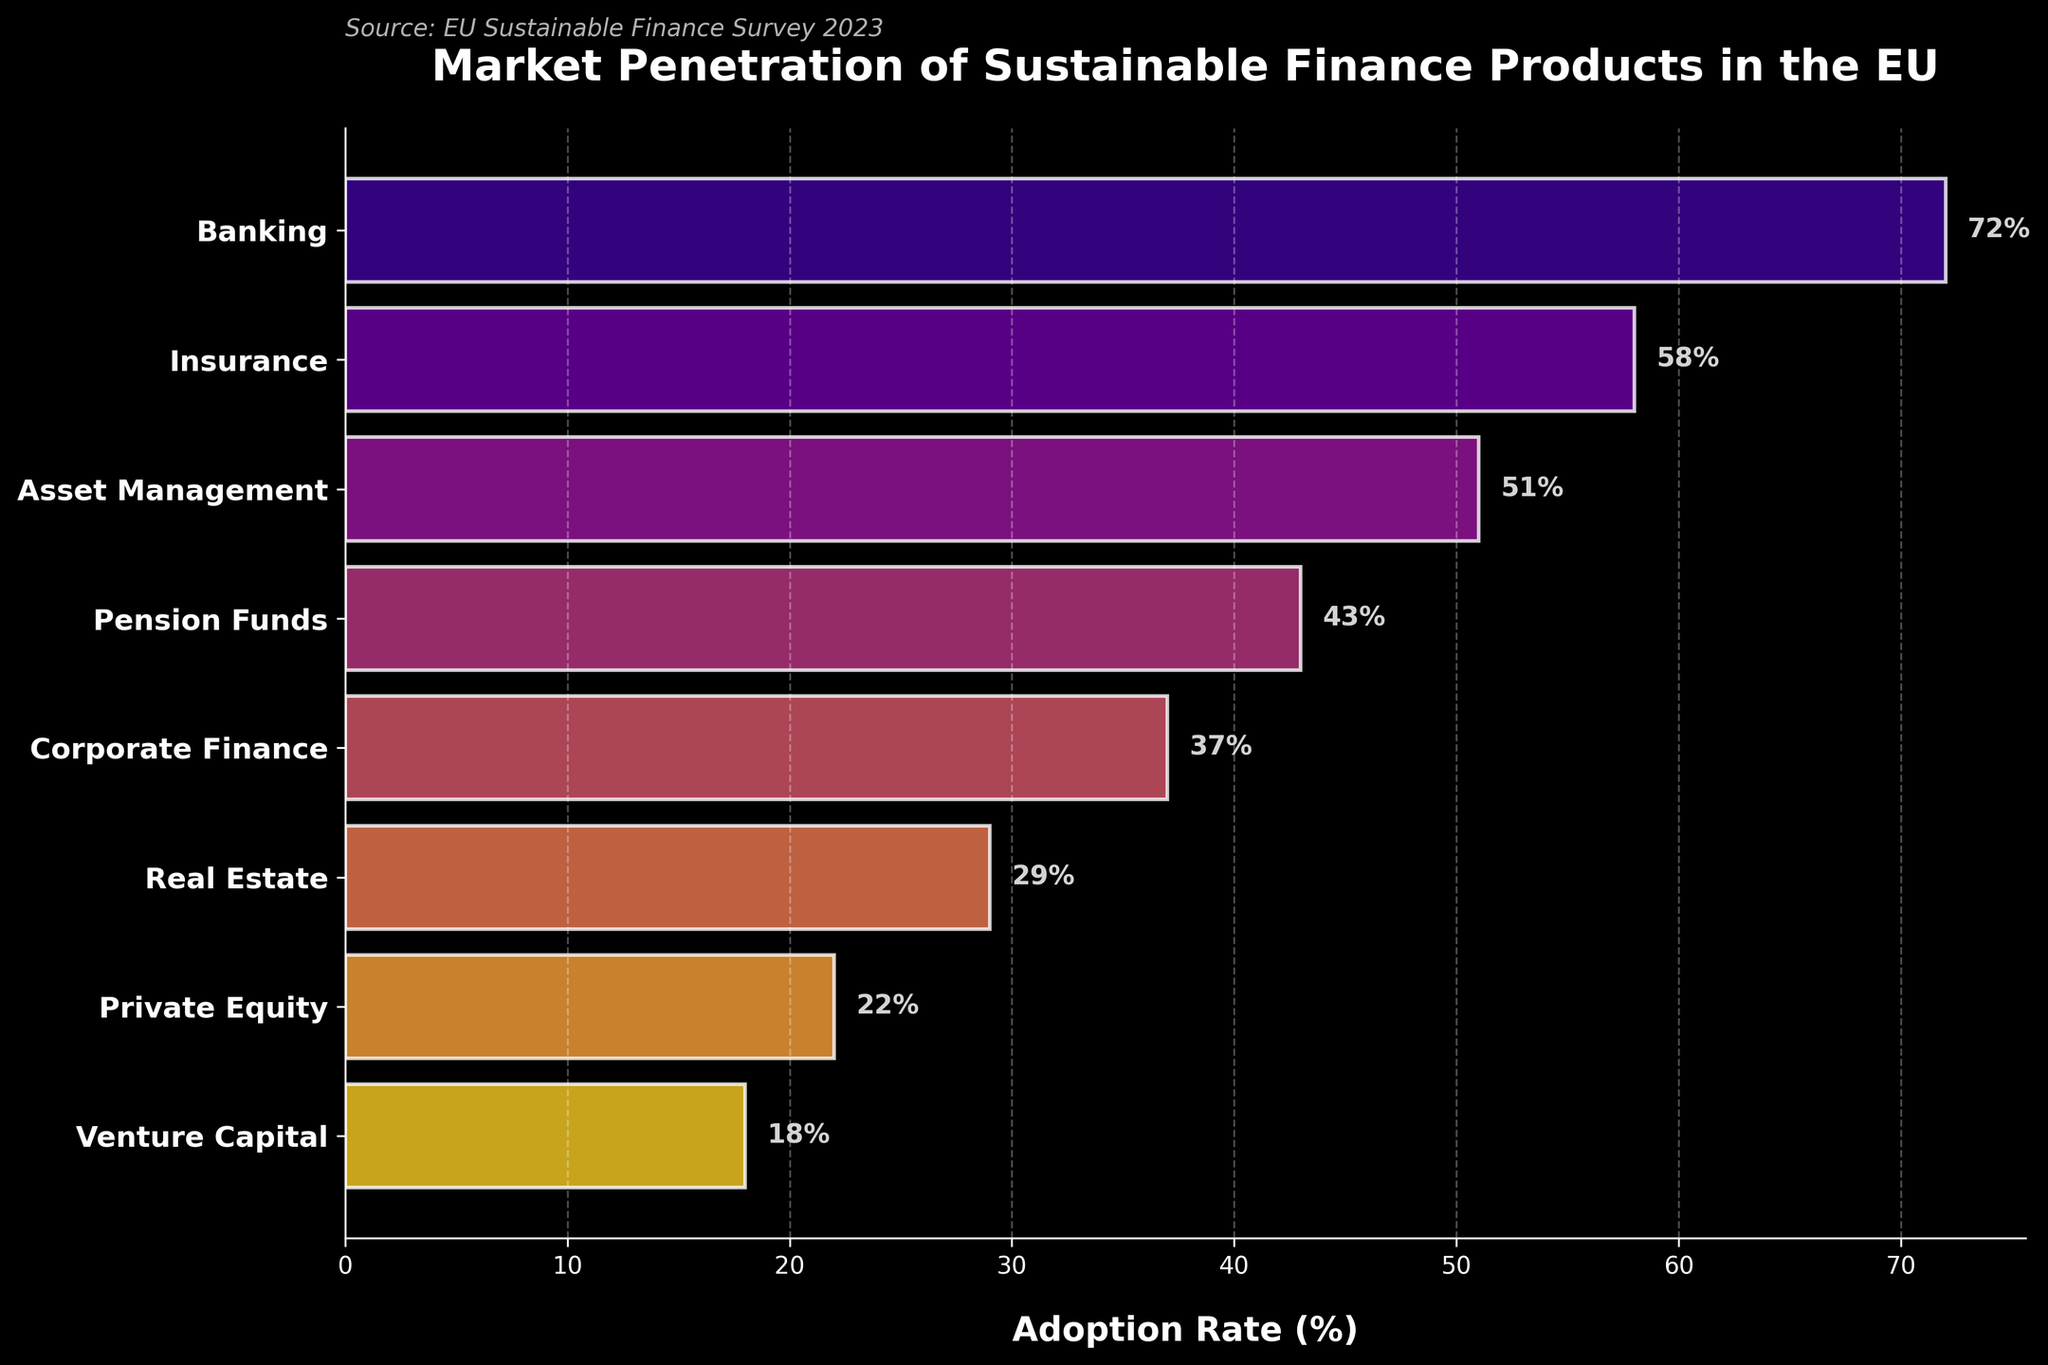What sector has the highest market penetration of sustainable finance products? The sector with the highest market penetration can be identified as the bar on the plot with the largest adoption rate. The 'Banking' sector has the highest adoption rate at 72%.
Answer: Banking What is the title of the funnel chart? The title of the funnel chart is displayed at the top of the figure, which reads 'Market Penetration of Sustainable Finance Products in the EU'.
Answer: Market Penetration of Sustainable Finance Products in the EU What is the approximate difference in adoption rates between the Banking and Venture Capital sectors? The adoption rate for the Banking sector is 72% and for Venture Capital is 18%. The difference is calculated as 72 - 18 = 54%.
Answer: 54% How many sectors are displayed in this funnel chart? The number of sectors can be counted by noting the number of bars in the funnel chart. There are eight sectors listed.
Answer: Eight What is the median adoption rate of the listed sectors? To find the median, list all the adoption rates in ascending order: 18, 22, 29, 37, 43, 51, 58, 72. The median is the average of the middle two numbers (37 and 43), giving (37 + 43) / 2 = 40%.
Answer: 40% Which sector has a lower adoption rate, Insurance or Asset Management? The adoption rate for Insurance is 58% and for Asset Management is 51%. By comparing the two, Asset Management has a lower adoption rate.
Answer: Asset Management What is the average adoption rate of the sectors listed? To find the average, sum all the adoption rates and divide by the number of sectors. (72 + 58 + 51 + 43 + 37 + 29 + 22 + 18) / 8 = 41.25%.
Answer: 41.25% Which sector ranks fourth in terms of market penetration of sustainable finance products? By ranking the sectors in descending order based on their adoption rates, the fourth highest is the 'Pension Funds' sector with a 43% adoption rate.
Answer: Pension Funds 